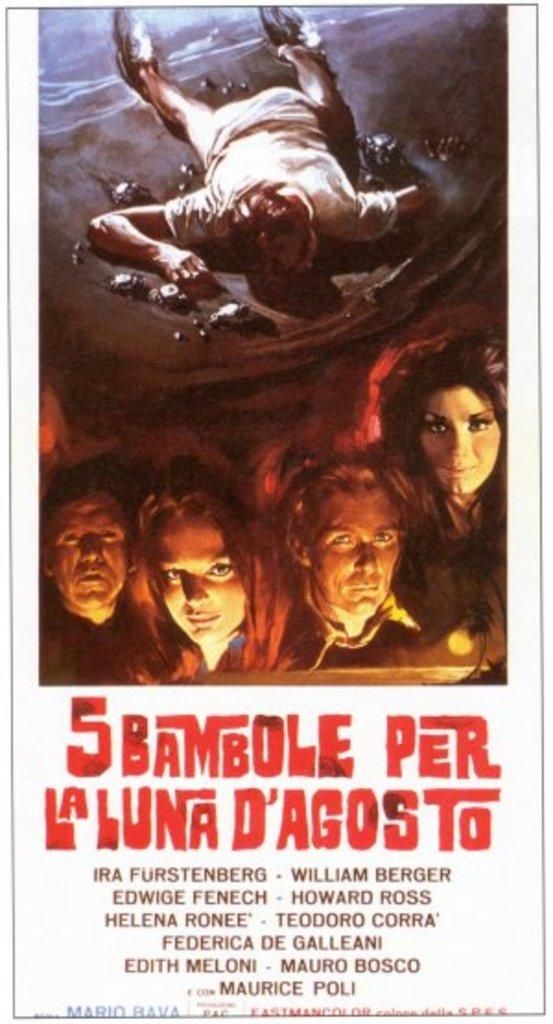<image>
Describe the image concisely. movie poster for 5 bambole per laluna d'agosto featuring people looking ahead and someone face down 